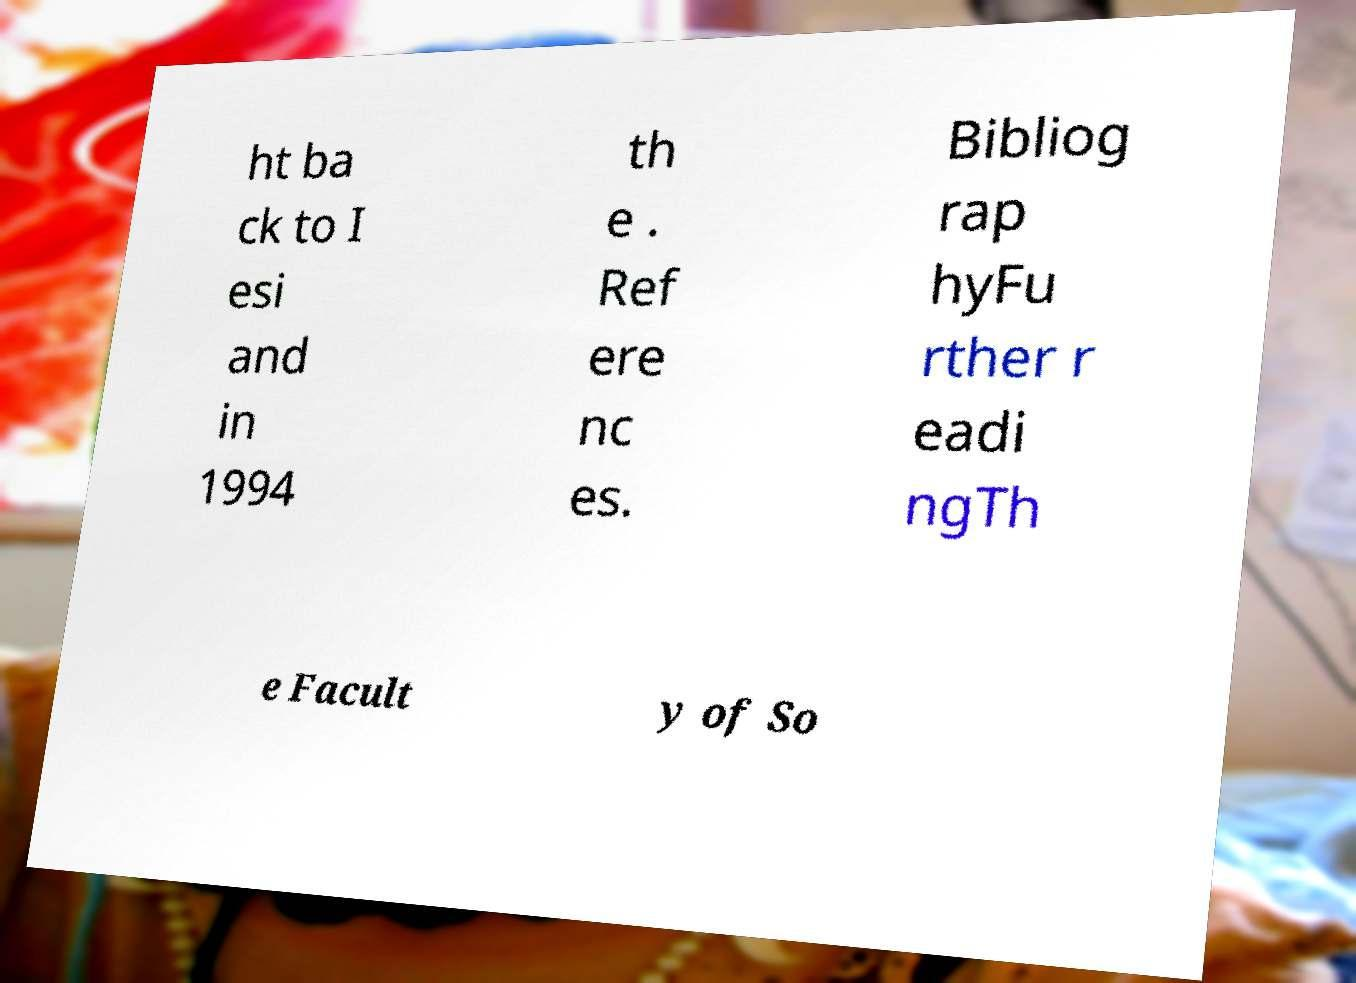Please read and relay the text visible in this image. What does it say? ht ba ck to I esi and in 1994 th e . Ref ere nc es. Bibliog rap hyFu rther r eadi ngTh e Facult y of So 